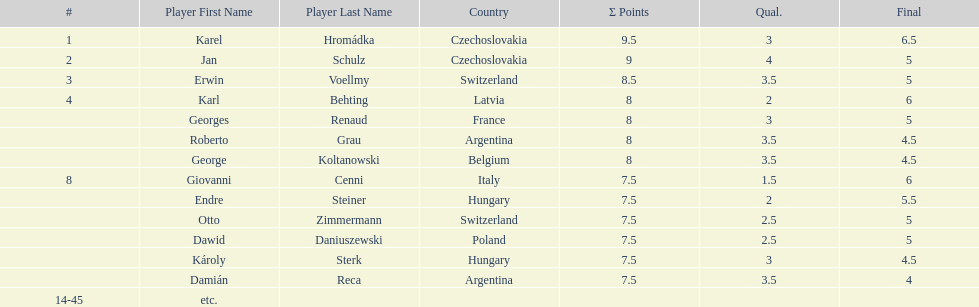How many countries had more than one player in the consolation cup? 4. 